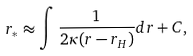Convert formula to latex. <formula><loc_0><loc_0><loc_500><loc_500>r _ { \ast } \approx \int \frac { 1 } { 2 \kappa ( r - r _ { H } ) } d r + C ,</formula> 